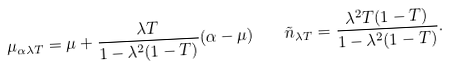Convert formula to latex. <formula><loc_0><loc_0><loc_500><loc_500>\mu _ { \alpha \lambda T } = \mu + \frac { \lambda T } { 1 - \lambda ^ { 2 } ( 1 - T ) } ( \alpha - \mu ) \quad \tilde { n } _ { \lambda T } = \frac { \lambda ^ { 2 } T ( 1 - T ) } { 1 - \lambda ^ { 2 } ( 1 - T ) } .</formula> 